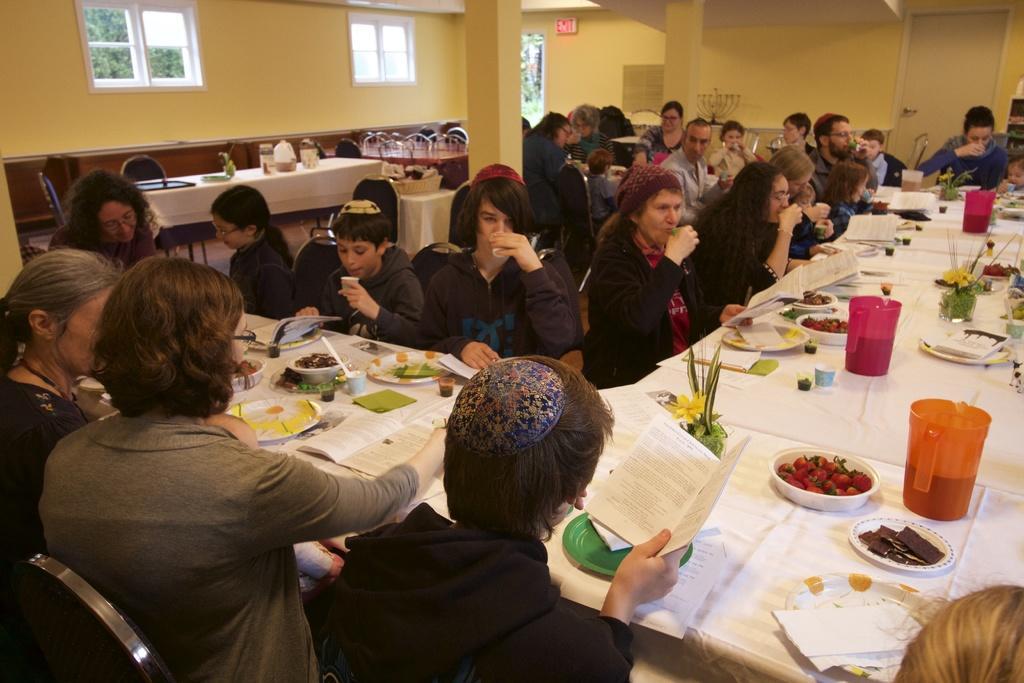Can you describe this image briefly? In this image I see lot of people sitting on the chairs and there are tables in front of them and there are lot of plates and food in it and I can also see few books, cups and jars. In the background I see the wall, window and the door. 